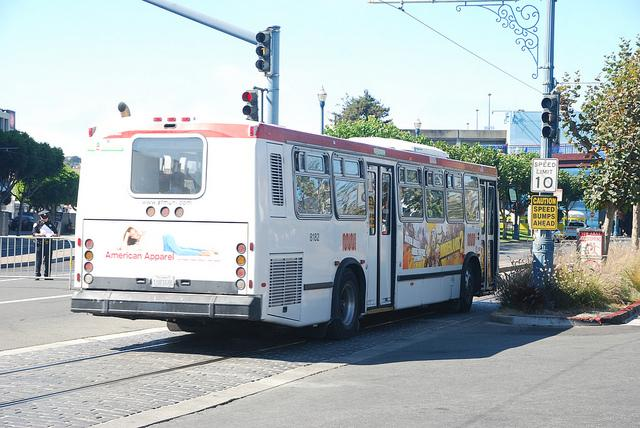Where is the bus located? Please explain your reasoning. bus lane. The bus is in a lane. 